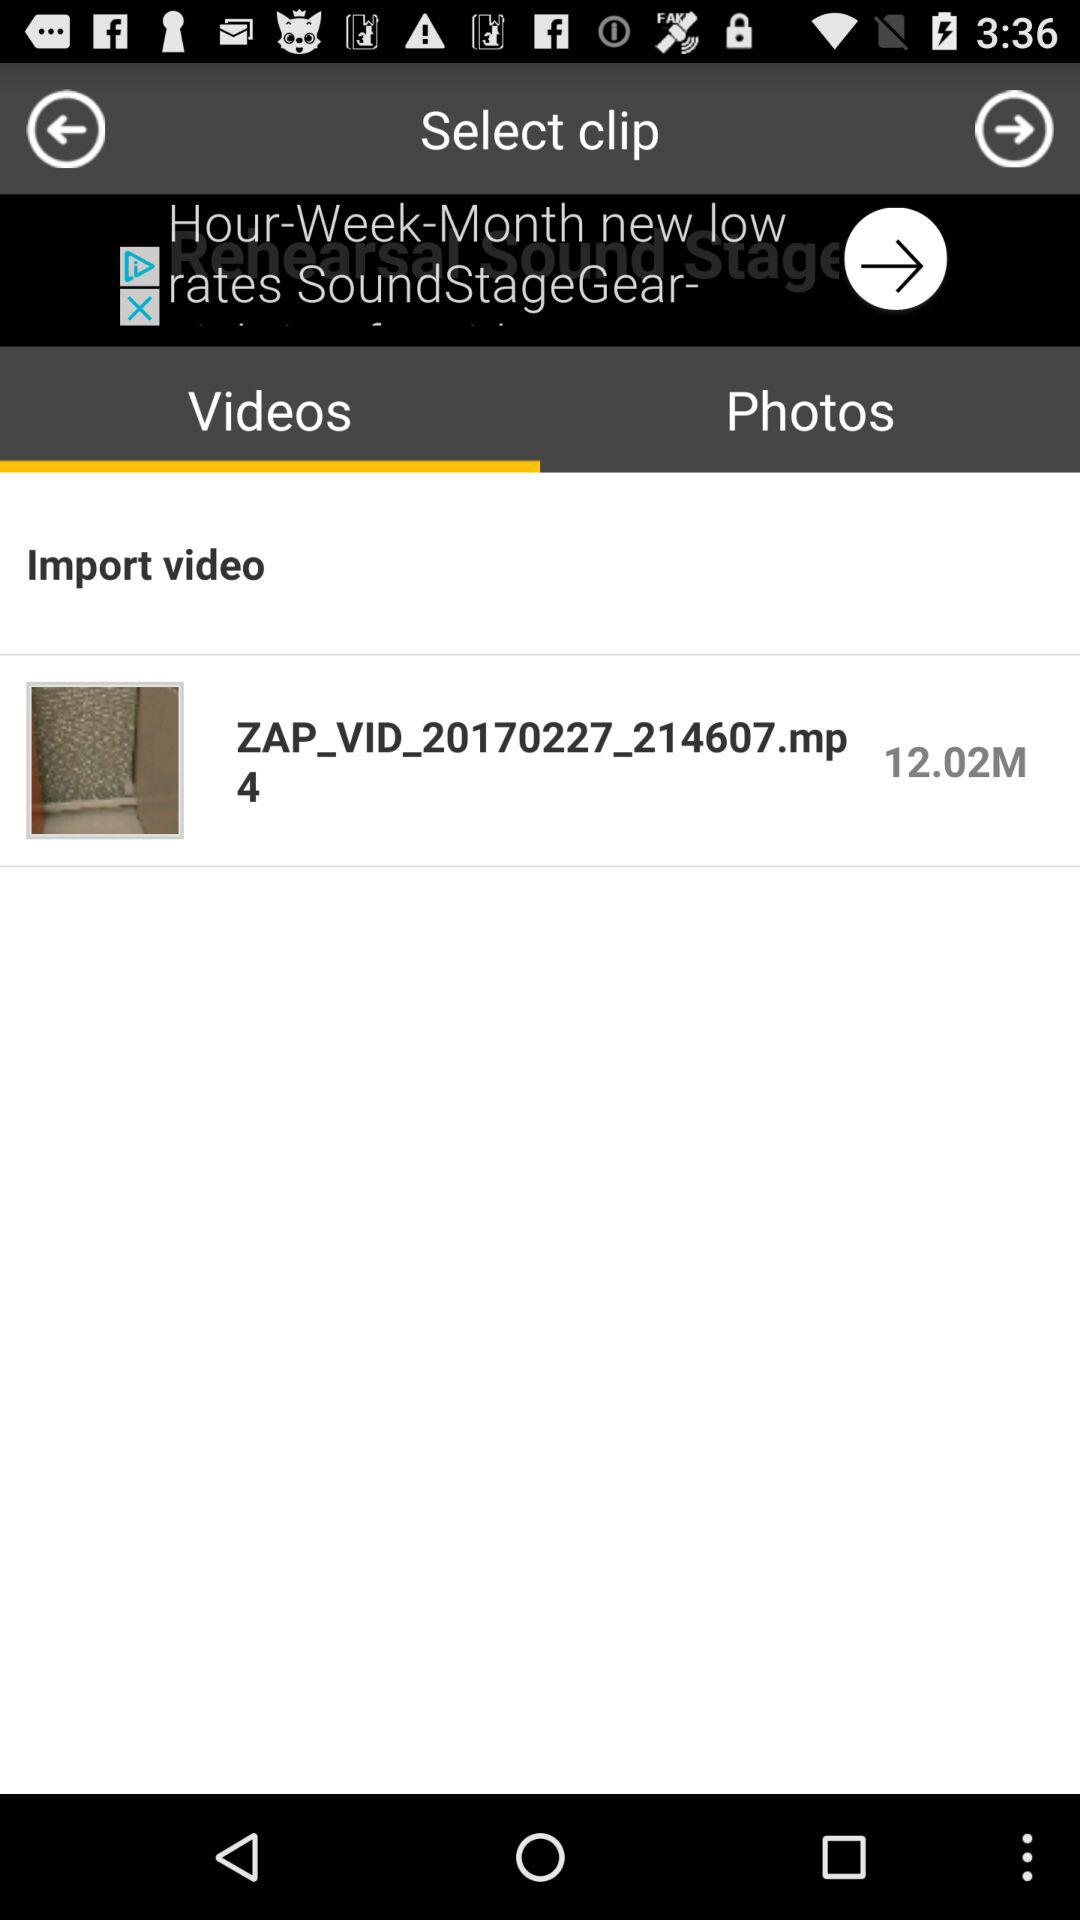What is the time of the import video?
When the provided information is insufficient, respond with <no answer>. <no answer> 